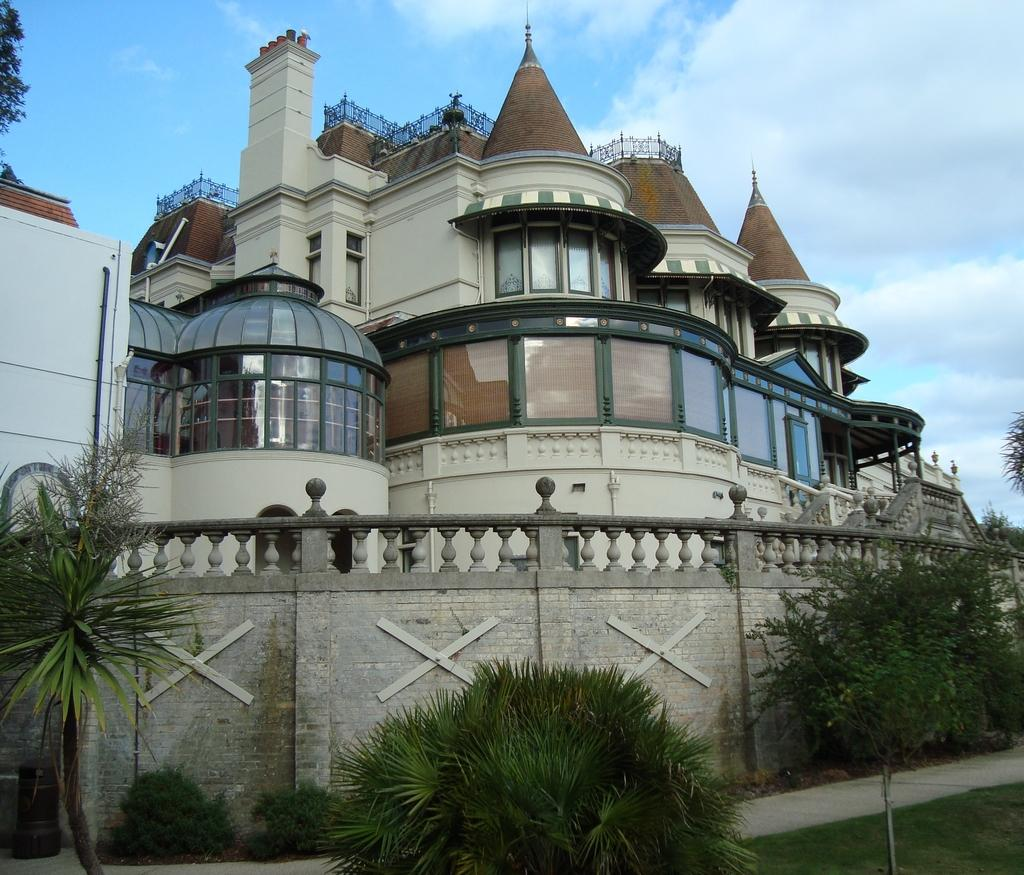What type of structures can be seen in the image? There are buildings in the image. What natural elements are present in the image? There are trees in the image. What type of barrier is visible in the image? There is a compound wall in the image. How would you describe the sky in the image? The sky is blue and cloudy in the image. How many divisions are there in the list of buildings in the image? There is no list of buildings or divisions present in the image. 